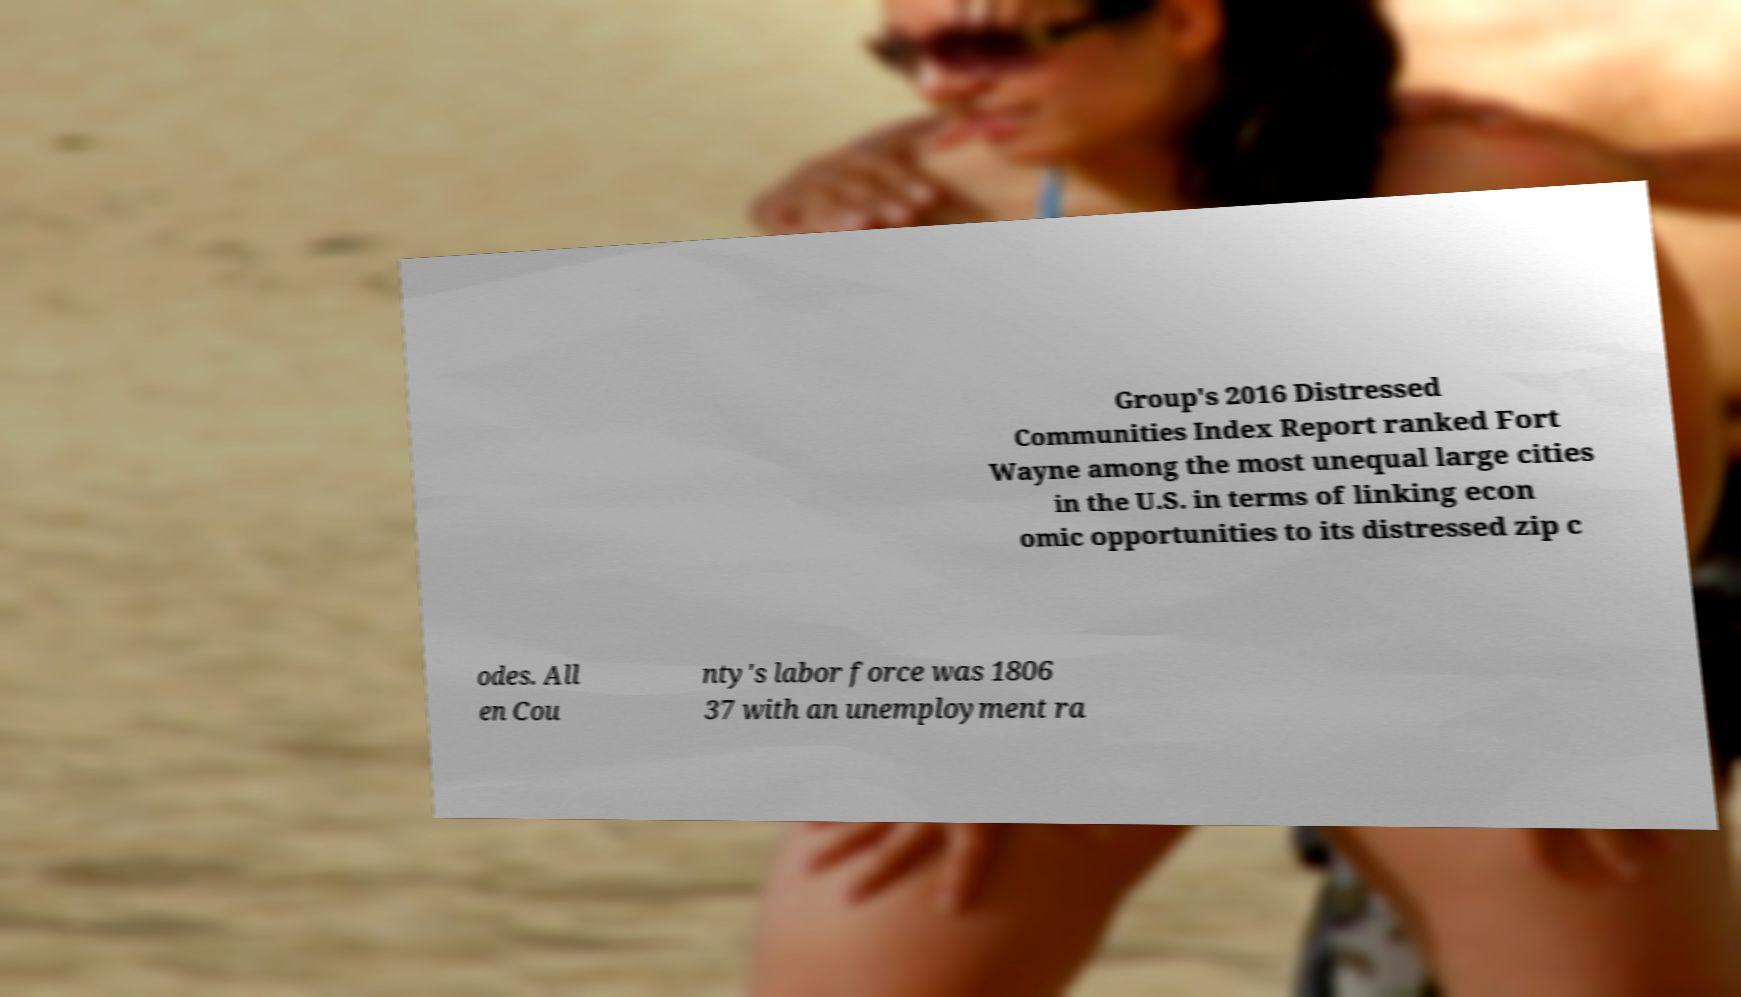Could you assist in decoding the text presented in this image and type it out clearly? Group's 2016 Distressed Communities Index Report ranked Fort Wayne among the most unequal large cities in the U.S. in terms of linking econ omic opportunities to its distressed zip c odes. All en Cou nty's labor force was 1806 37 with an unemployment ra 